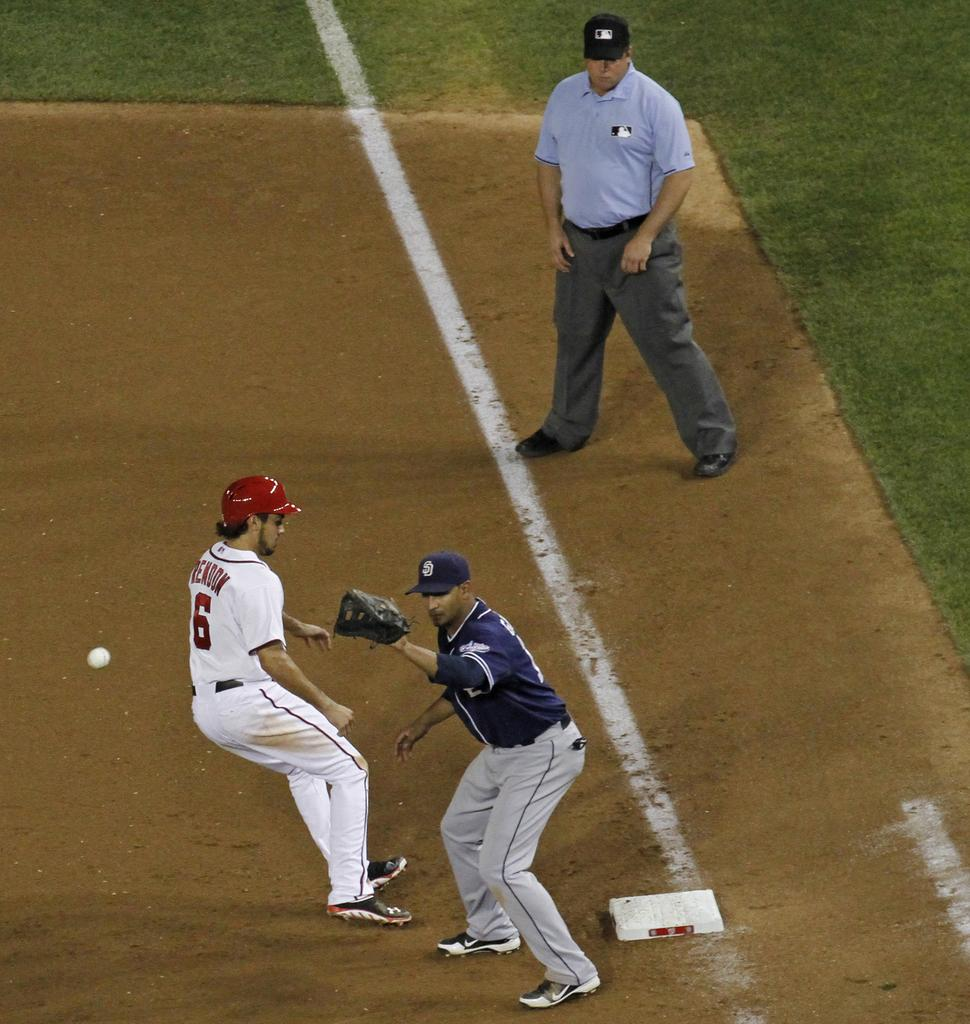<image>
Summarize the visual content of the image. A baseball player in the number six is approaching the base. 